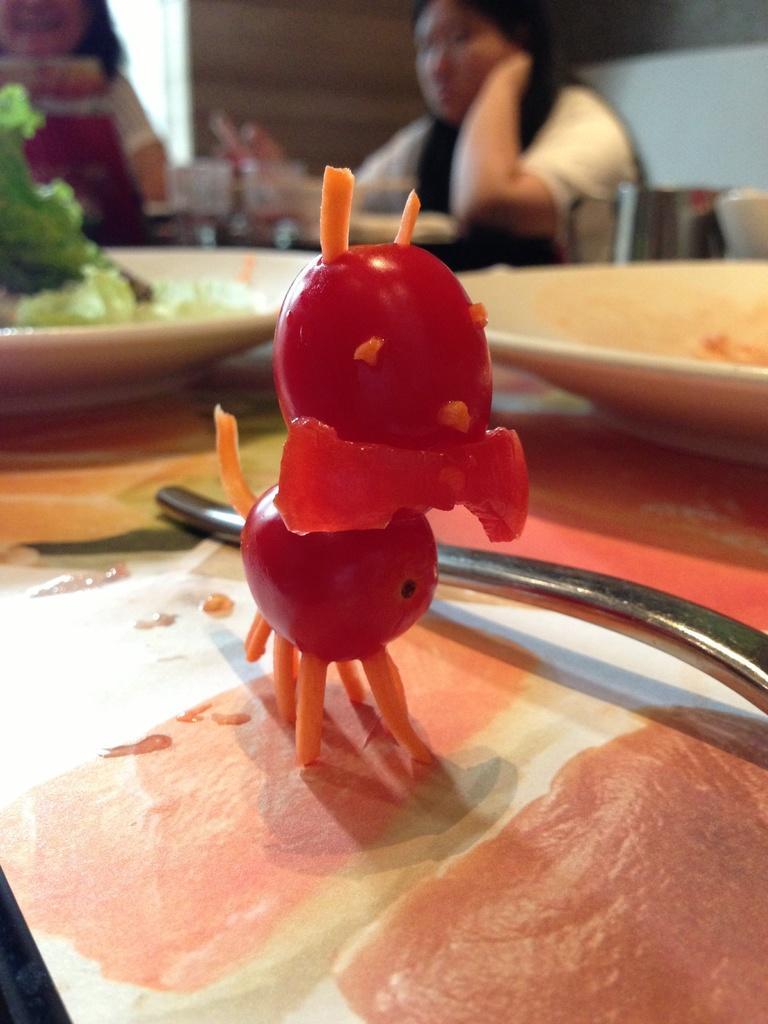How would you summarize this image in a sentence or two? In this image, we can see some food items with plates. Top of the image, we can see two human , wall. 